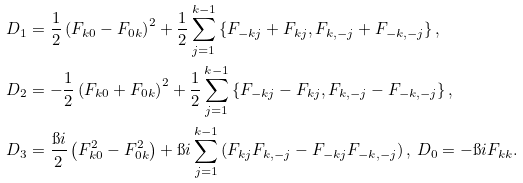<formula> <loc_0><loc_0><loc_500><loc_500>D _ { 1 } & = \frac { 1 } { 2 } \left ( F _ { k 0 } - F _ { 0 k } \right ) ^ { 2 } + \frac { 1 } { 2 } \sum _ { j = 1 } ^ { k - 1 } \left \{ F _ { - k j } + F _ { k j } , F _ { k , - j } + F _ { - k , - j } \right \} , \\ D _ { 2 } & = - \frac { 1 } { 2 } \left ( F _ { k 0 } + F _ { 0 k } \right ) ^ { 2 } + \frac { 1 } { 2 } \sum _ { j = 1 } ^ { k - 1 } \left \{ F _ { - k j } - F _ { k j } , F _ { k , - j } - F _ { - k , - j } \right \} , \\ D _ { 3 } & = \frac { \i i } 2 \left ( F _ { k 0 } ^ { 2 } - F _ { 0 k } ^ { 2 } \right ) + \i i \sum _ { j = 1 } ^ { k - 1 } \left ( F _ { k j } F _ { k , - j } - F _ { - k j } F _ { - k , - j } \right ) , \, D _ { 0 } = - \i i F _ { k k } .</formula> 